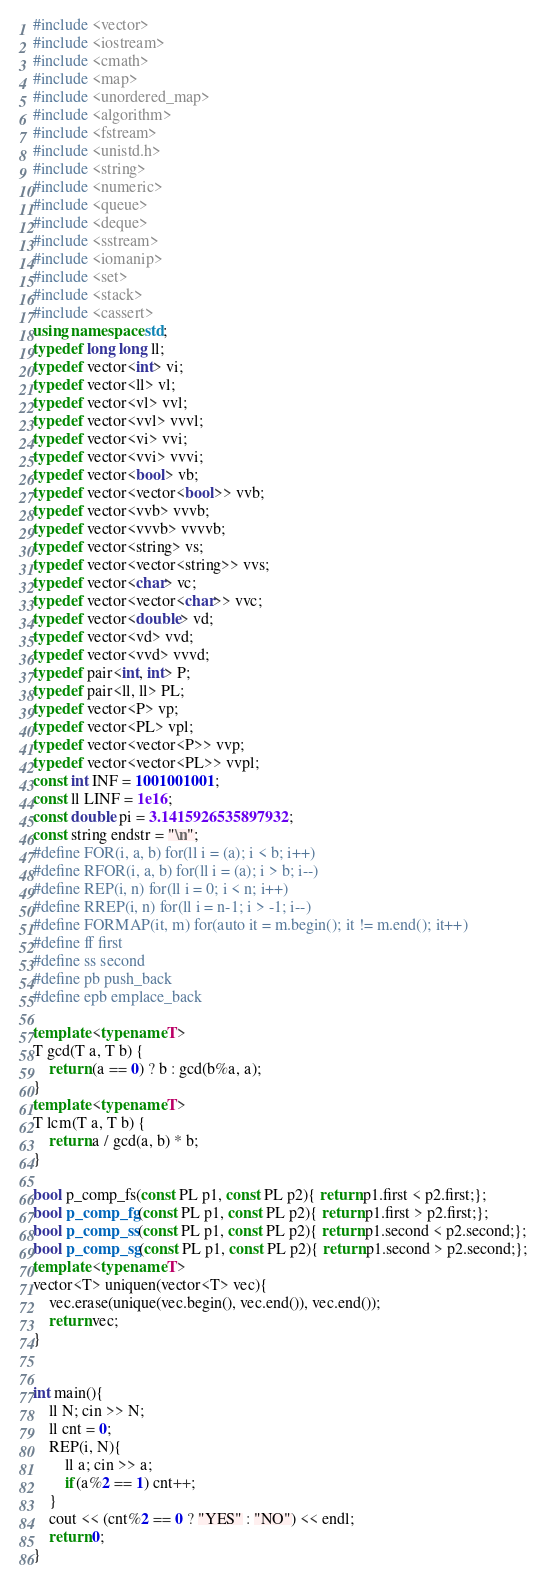Convert code to text. <code><loc_0><loc_0><loc_500><loc_500><_C++_>#include <vector>
#include <iostream>
#include <cmath>
#include <map>
#include <unordered_map>
#include <algorithm>
#include <fstream>
#include <unistd.h>
#include <string>
#include <numeric>
#include <queue>
#include <deque>
#include <sstream>
#include <iomanip>
#include <set>
#include <stack>
#include <cassert>
using namespace std;
typedef long long ll;
typedef vector<int> vi;
typedef vector<ll> vl;
typedef vector<vl> vvl;
typedef vector<vvl> vvvl;
typedef vector<vi> vvi;
typedef vector<vvi> vvvi;
typedef vector<bool> vb;
typedef vector<vector<bool>> vvb;
typedef vector<vvb> vvvb;
typedef vector<vvvb> vvvvb;
typedef vector<string> vs;
typedef vector<vector<string>> vvs;
typedef vector<char> vc;
typedef vector<vector<char>> vvc;
typedef vector<double> vd;
typedef vector<vd> vvd;
typedef vector<vvd> vvvd;
typedef pair<int, int> P;
typedef pair<ll, ll> PL;
typedef vector<P> vp;
typedef vector<PL> vpl;
typedef vector<vector<P>> vvp;
typedef vector<vector<PL>> vvpl;
const int INF = 1001001001;
const ll LINF = 1e16;
const double pi = 3.1415926535897932;
const string endstr = "\n";
#define FOR(i, a, b) for(ll i = (a); i < b; i++)
#define RFOR(i, a, b) for(ll i = (a); i > b; i--)
#define REP(i, n) for(ll i = 0; i < n; i++)
#define RREP(i, n) for(ll i = n-1; i > -1; i--)
#define FORMAP(it, m) for(auto it = m.begin(); it != m.end(); it++)
#define ff first
#define ss second
#define pb push_back
#define epb emplace_back

template <typename T>
T gcd(T a, T b) {
    return (a == 0) ? b : gcd(b%a, a);
}
template <typename T>
T lcm(T a, T b) {
    return a / gcd(a, b) * b;
}

bool p_comp_fs(const PL p1, const PL p2){ return p1.first < p2.first;};
bool p_comp_fg(const PL p1, const PL p2){ return p1.first > p2.first;};
bool p_comp_ss(const PL p1, const PL p2){ return p1.second < p2.second;};
bool p_comp_sg(const PL p1, const PL p2){ return p1.second > p2.second;};
template <typename T>
vector<T> uniquen(vector<T> vec){
    vec.erase(unique(vec.begin(), vec.end()), vec.end());
    return vec;
}


int main(){
    ll N; cin >> N;
    ll cnt = 0;
    REP(i, N){
        ll a; cin >> a;
        if(a%2 == 1) cnt++;
    }
    cout << (cnt%2 == 0 ? "YES" : "NO") << endl;
    return 0;
}
</code> 